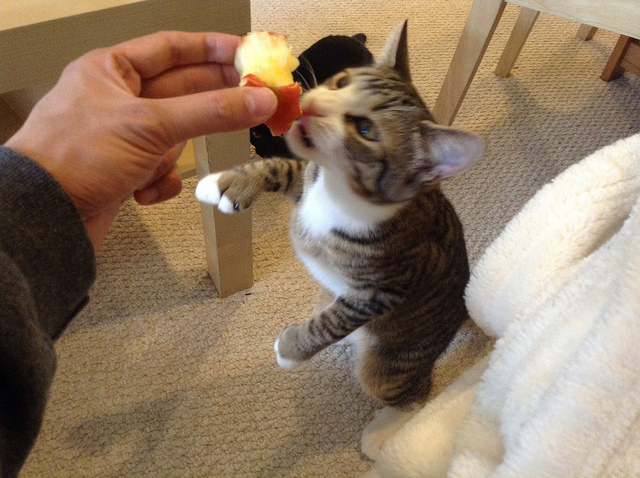<image>Why is the person feeding the kitten this way? I don't know why the person is feeding the kitten this way. It might be for teaching it a trick, because the kitten is hungry, or to make it stand. Why is the person feeding the kitten this way? I don't know why the person is feeding the kitten this way. It could be for various reasons like teaching it a trick, because the kitten is hungry, or to make it stand. 